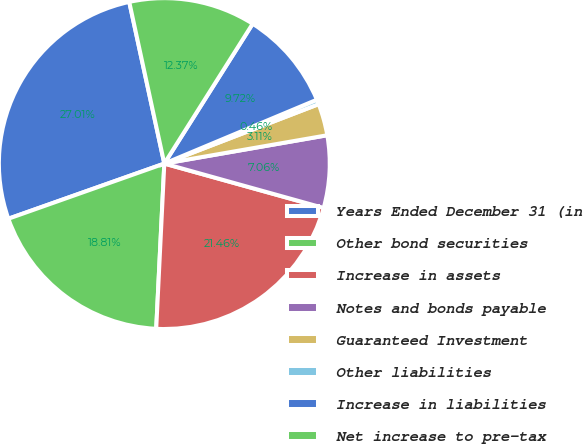<chart> <loc_0><loc_0><loc_500><loc_500><pie_chart><fcel>Years Ended December 31 (in<fcel>Other bond securities<fcel>Increase in assets<fcel>Notes and bonds payable<fcel>Guaranteed Investment<fcel>Other liabilities<fcel>Increase in liabilities<fcel>Net increase to pre-tax<nl><fcel>27.01%<fcel>18.81%<fcel>21.46%<fcel>7.06%<fcel>3.11%<fcel>0.46%<fcel>9.72%<fcel>12.37%<nl></chart> 